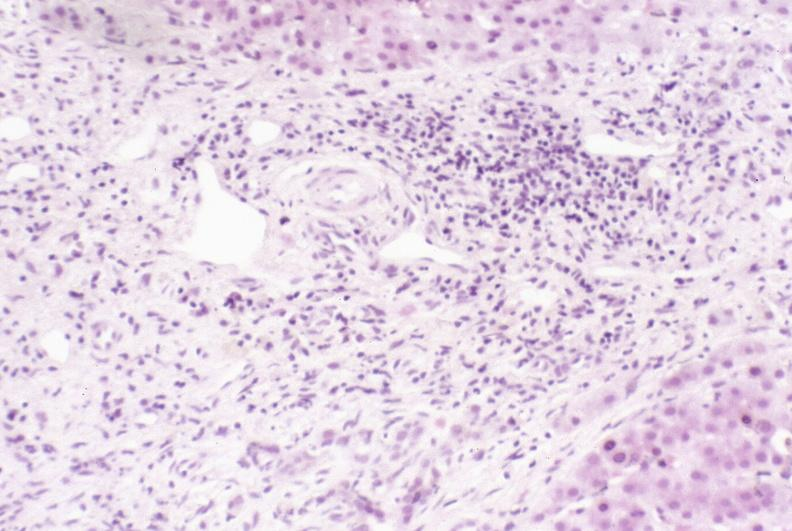s fallopian tube present?
Answer the question using a single word or phrase. No 